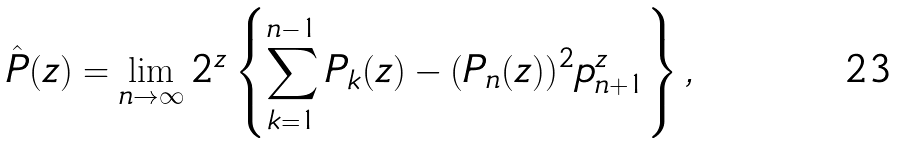Convert formula to latex. <formula><loc_0><loc_0><loc_500><loc_500>\hat { P } ( z ) = \lim _ { n \to \infty } 2 ^ { z } \left \{ \sum _ { k = 1 } ^ { n - 1 } P _ { k } ( z ) - ( P _ { n } ( z ) ) ^ { 2 } p _ { n + 1 } ^ { z } \right \} ,</formula> 